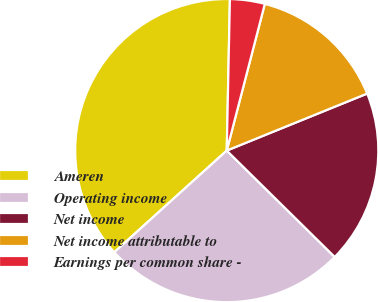<chart> <loc_0><loc_0><loc_500><loc_500><pie_chart><fcel>Ameren<fcel>Operating income<fcel>Net income<fcel>Net income attributable to<fcel>Earnings per common share -<nl><fcel>37.03%<fcel>25.92%<fcel>18.52%<fcel>14.82%<fcel>3.71%<nl></chart> 